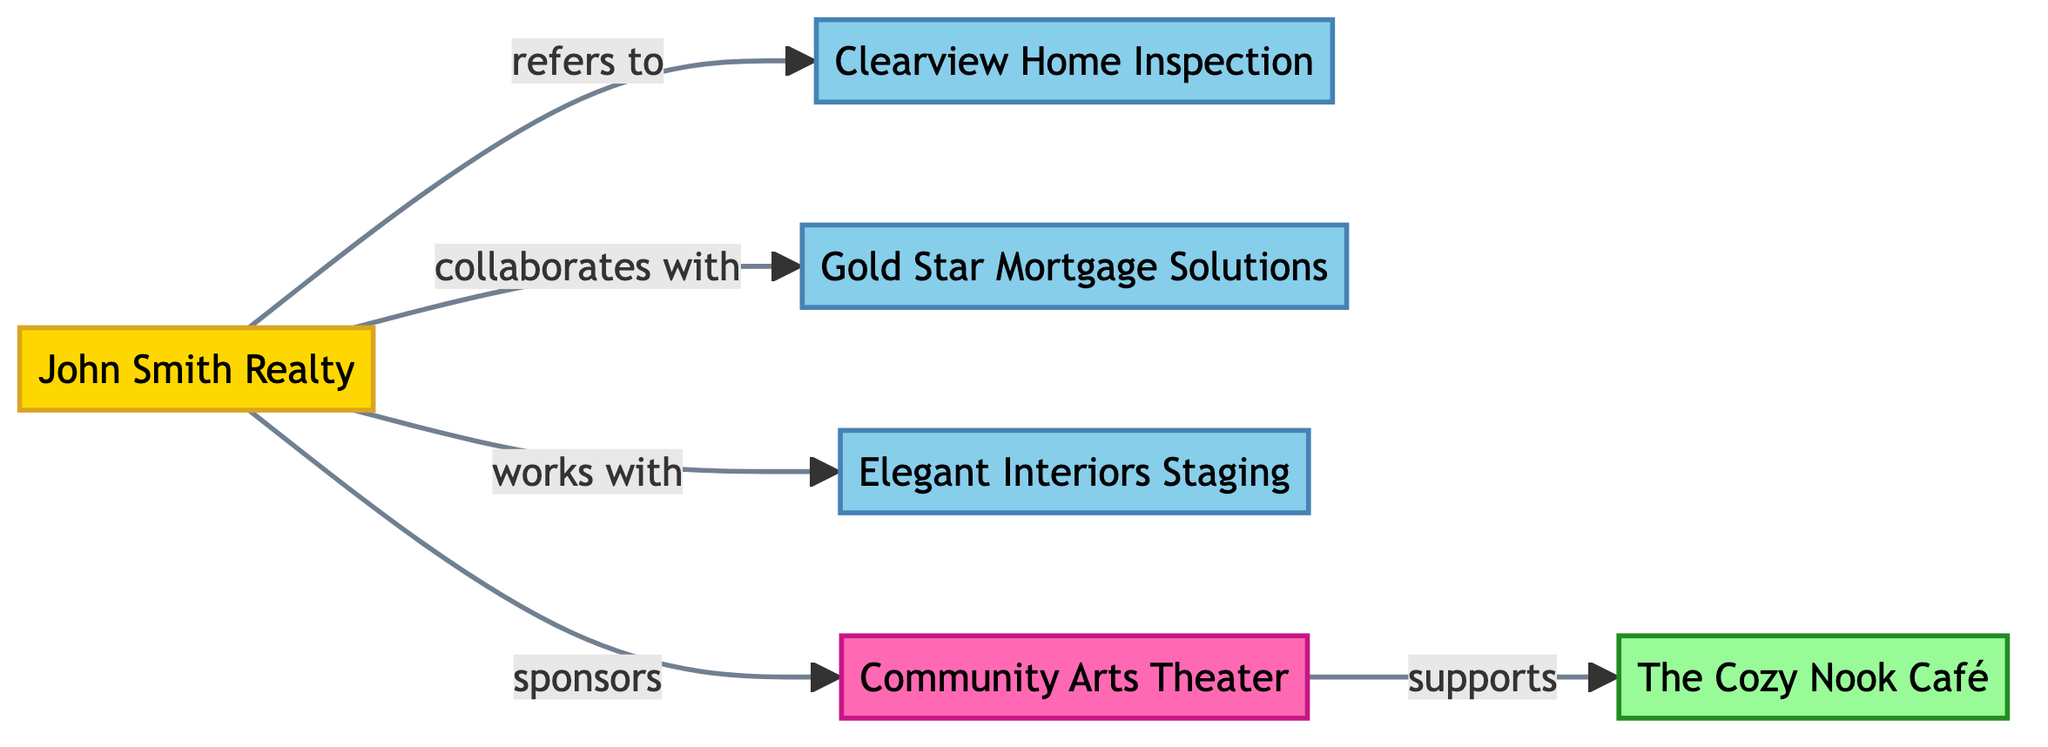What is the total number of nodes in the diagram? The diagram lists six distinct nodes: John Smith Realty, Clearview Home Inspection, Gold Star Mortgage Solutions, Elegant Interiors Staging, Community Arts Theater, and The Cozy Nook Café. Counting these gives a total of 6 nodes.
Answer: 6 Which service provider does the real estate agent refer to? The flow from John Smith Realty leads to Clearview Home Inspection, indicating that the real estate agent refers to this specific home inspector.
Answer: Clearview Home Inspection How many relationships does John Smith Realty have with other nodes? John Smith Realty connects to four different entities: Clearview Home Inspection, Gold Star Mortgage Solutions, Elegant Interiors Staging, and Community Arts Theater. This results in a total of 4 relationships.
Answer: 4 What type of relationship exists between Community Arts Theater and The Cozy Nook Café? An arrow leads from Community Arts Theater to The Cozy Nook Café, labeled "supports," indicating this specific relationship.
Answer: supports Who does John Smith Realty collaborate with? The diagram shows a collaboration line between John Smith Realty and Gold Star Mortgage Solutions, signifying that this is the entity with which the real estate agent collaborates.
Answer: Gold Star Mortgage Solutions Which node is categorized as a cultural partner? The diagram designates Community Arts Theater as a cultural partner, evident from its classification.
Answer: Community Arts Theater What type of business is Clearview Home Inspection? Clearview Home Inspection is categorized in the diagram as a service provider, reflecting its role in the network.
Answer: Service Provider Which node has a direct sponsorship relationship from John Smith Realty? The diagram indicates that John Smith Realty sponsors the Community Arts Theater, highlighting this direct sponsorship relationship.
Answer: Community Arts Theater How many service providers are involved in the diagram? The nodes represent three service providers: Clearview Home Inspection, Gold Star Mortgage Solutions, and Elegant Interiors Staging. Counting these gives a total of 3 service providers.
Answer: 3 